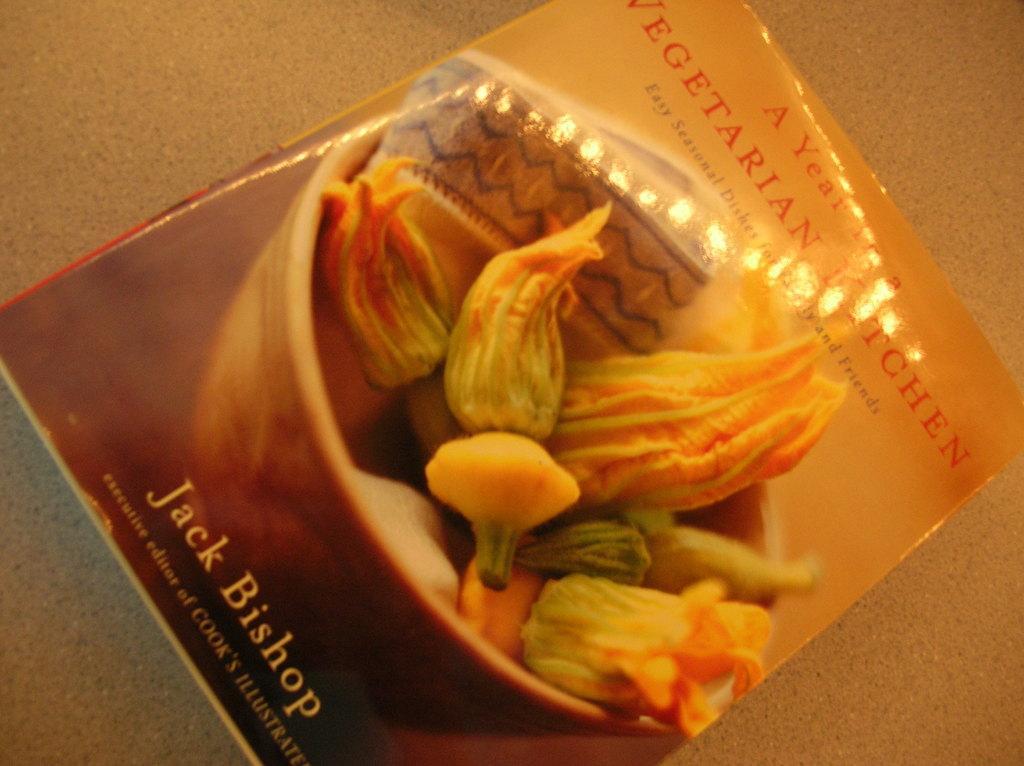How would you summarize this image in a sentence or two? In this image, we can see a poster with some images and text is placed on the ground. 